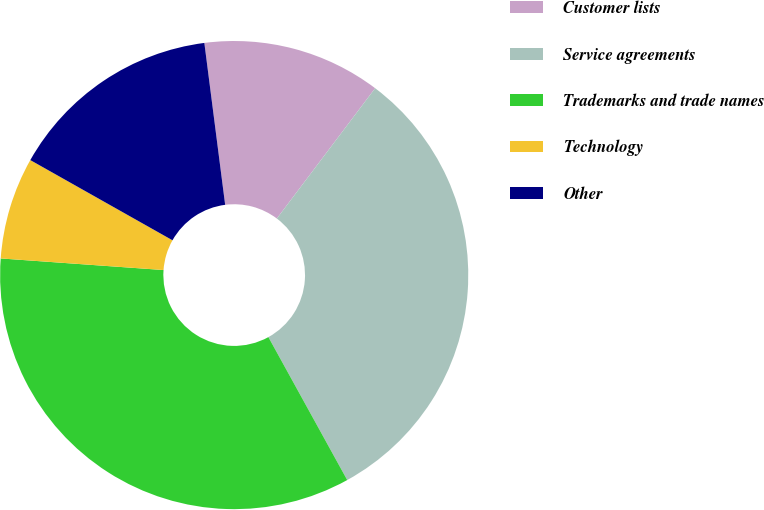Convert chart. <chart><loc_0><loc_0><loc_500><loc_500><pie_chart><fcel>Customer lists<fcel>Service agreements<fcel>Trademarks and trade names<fcel>Technology<fcel>Other<nl><fcel>12.32%<fcel>31.69%<fcel>34.15%<fcel>7.04%<fcel>14.79%<nl></chart> 